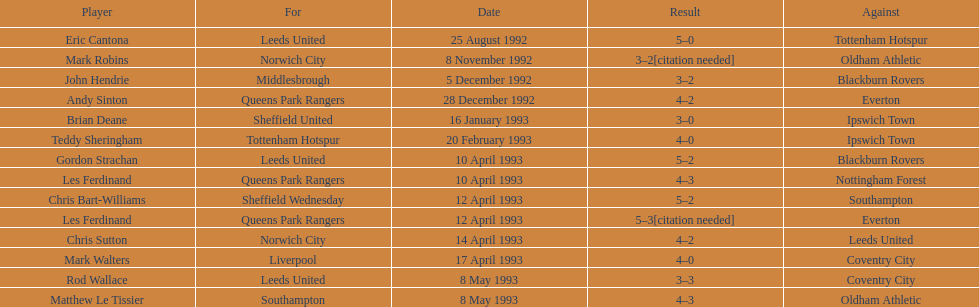Southampton played on may 8th, 1993, who was their opponent? Oldham Athletic. 